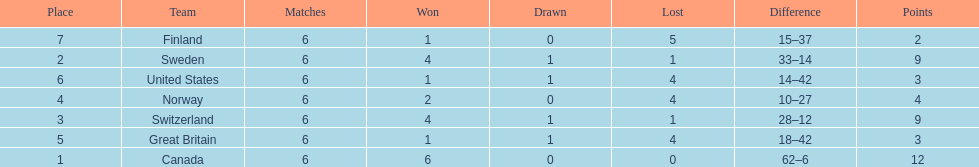How many teams won at least 2 games throughout the 1951 world ice hockey championships? 4. 